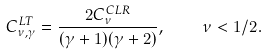<formula> <loc_0><loc_0><loc_500><loc_500>C ^ { L T } _ { \nu , \gamma } = \frac { 2 C _ { \nu } ^ { C L R } } { ( \gamma + 1 ) ( \gamma + 2 ) } , \quad \nu < 1 / 2 .</formula> 